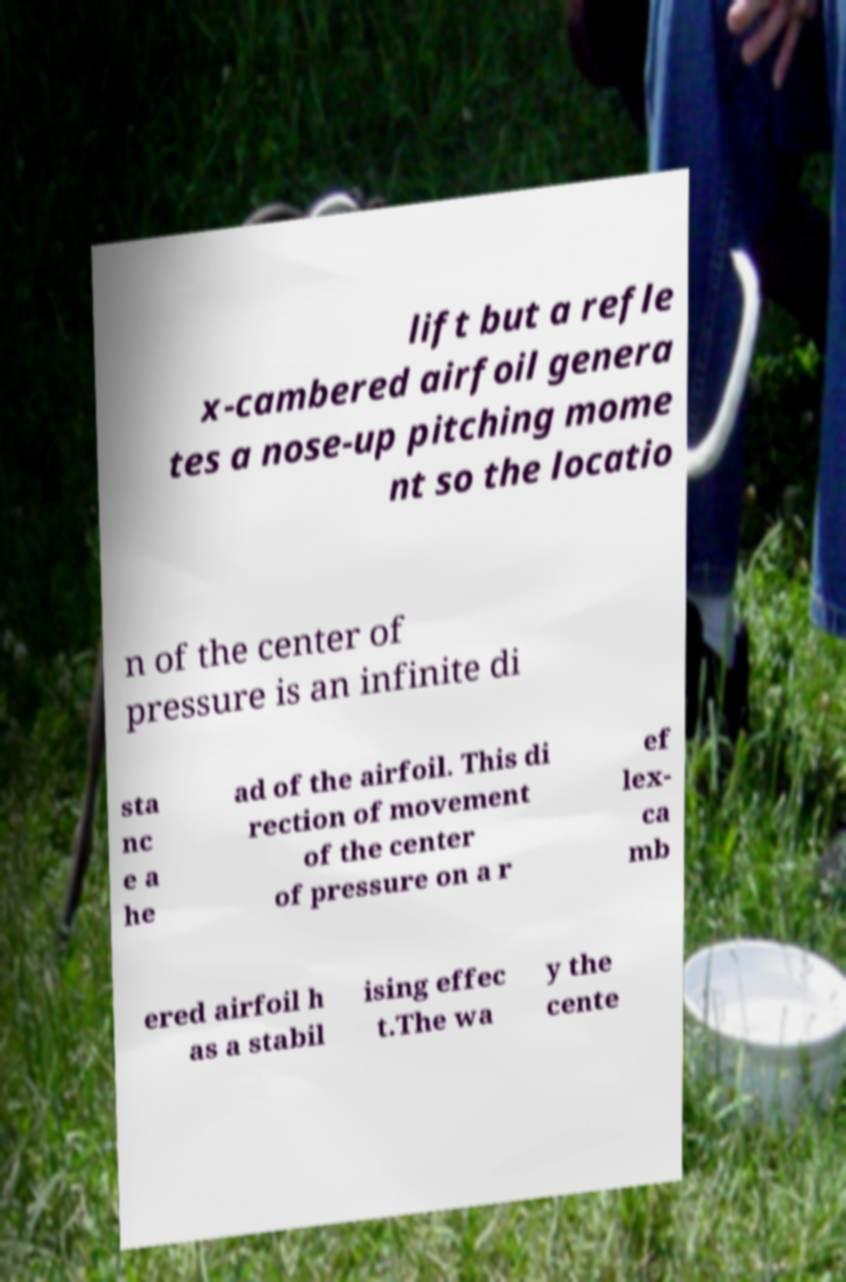I need the written content from this picture converted into text. Can you do that? lift but a refle x-cambered airfoil genera tes a nose-up pitching mome nt so the locatio n of the center of pressure is an infinite di sta nc e a he ad of the airfoil. This di rection of movement of the center of pressure on a r ef lex- ca mb ered airfoil h as a stabil ising effec t.The wa y the cente 